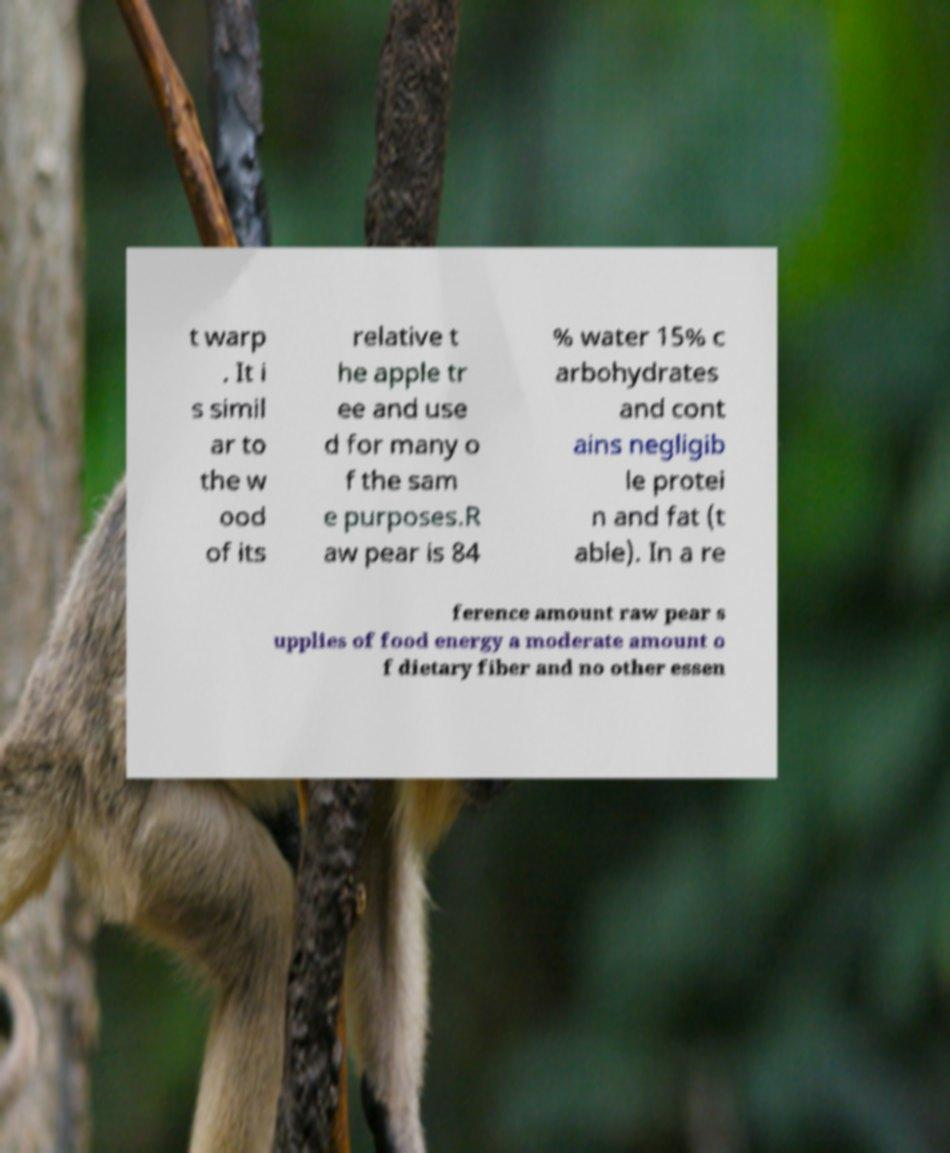What messages or text are displayed in this image? I need them in a readable, typed format. t warp . It i s simil ar to the w ood of its relative t he apple tr ee and use d for many o f the sam e purposes.R aw pear is 84 % water 15% c arbohydrates and cont ains negligib le protei n and fat (t able). In a re ference amount raw pear s upplies of food energy a moderate amount o f dietary fiber and no other essen 